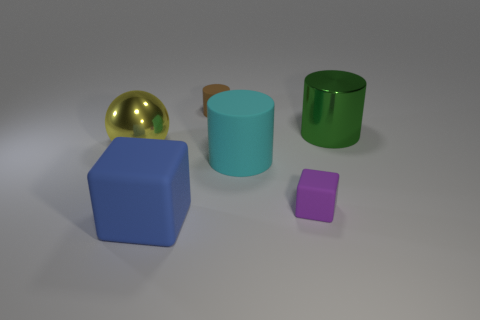What shape is the large metallic thing right of the block to the left of the small thing to the left of the tiny purple rubber cube?
Provide a succinct answer. Cylinder. There is a tiny matte thing to the right of the tiny brown matte thing; is it the same shape as the tiny rubber object behind the large yellow metal object?
Your response must be concise. No. How many other objects are there of the same material as the small block?
Provide a succinct answer. 3. There is another thing that is made of the same material as the large green object; what is its shape?
Offer a terse response. Sphere. Is the size of the blue block the same as the green metallic cylinder?
Your answer should be compact. Yes. What size is the block left of the big cylinder that is in front of the yellow metal object?
Provide a succinct answer. Large. How many balls are large matte objects or cyan rubber things?
Give a very brief answer. 0. Does the ball have the same size as the matte thing behind the big cyan rubber thing?
Keep it short and to the point. No. Are there more brown cylinders right of the yellow ball than purple blocks?
Give a very brief answer. No. The green thing that is made of the same material as the yellow object is what size?
Provide a short and direct response. Large. 